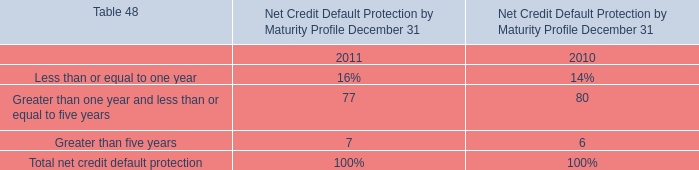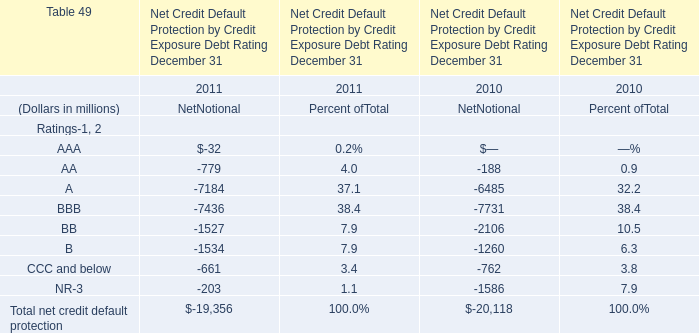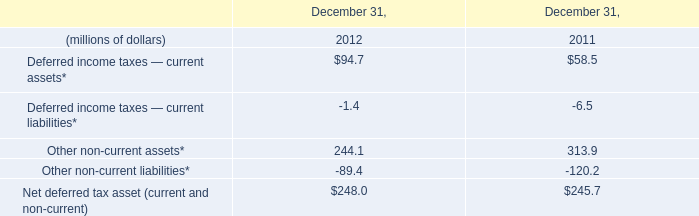What is the ratio of BB of NetNotional in Table 1 to the Other non-current liabilities* in Table 2 in 2011? 
Computations: (-1527 / -120.2)
Answer: 12.70383. 